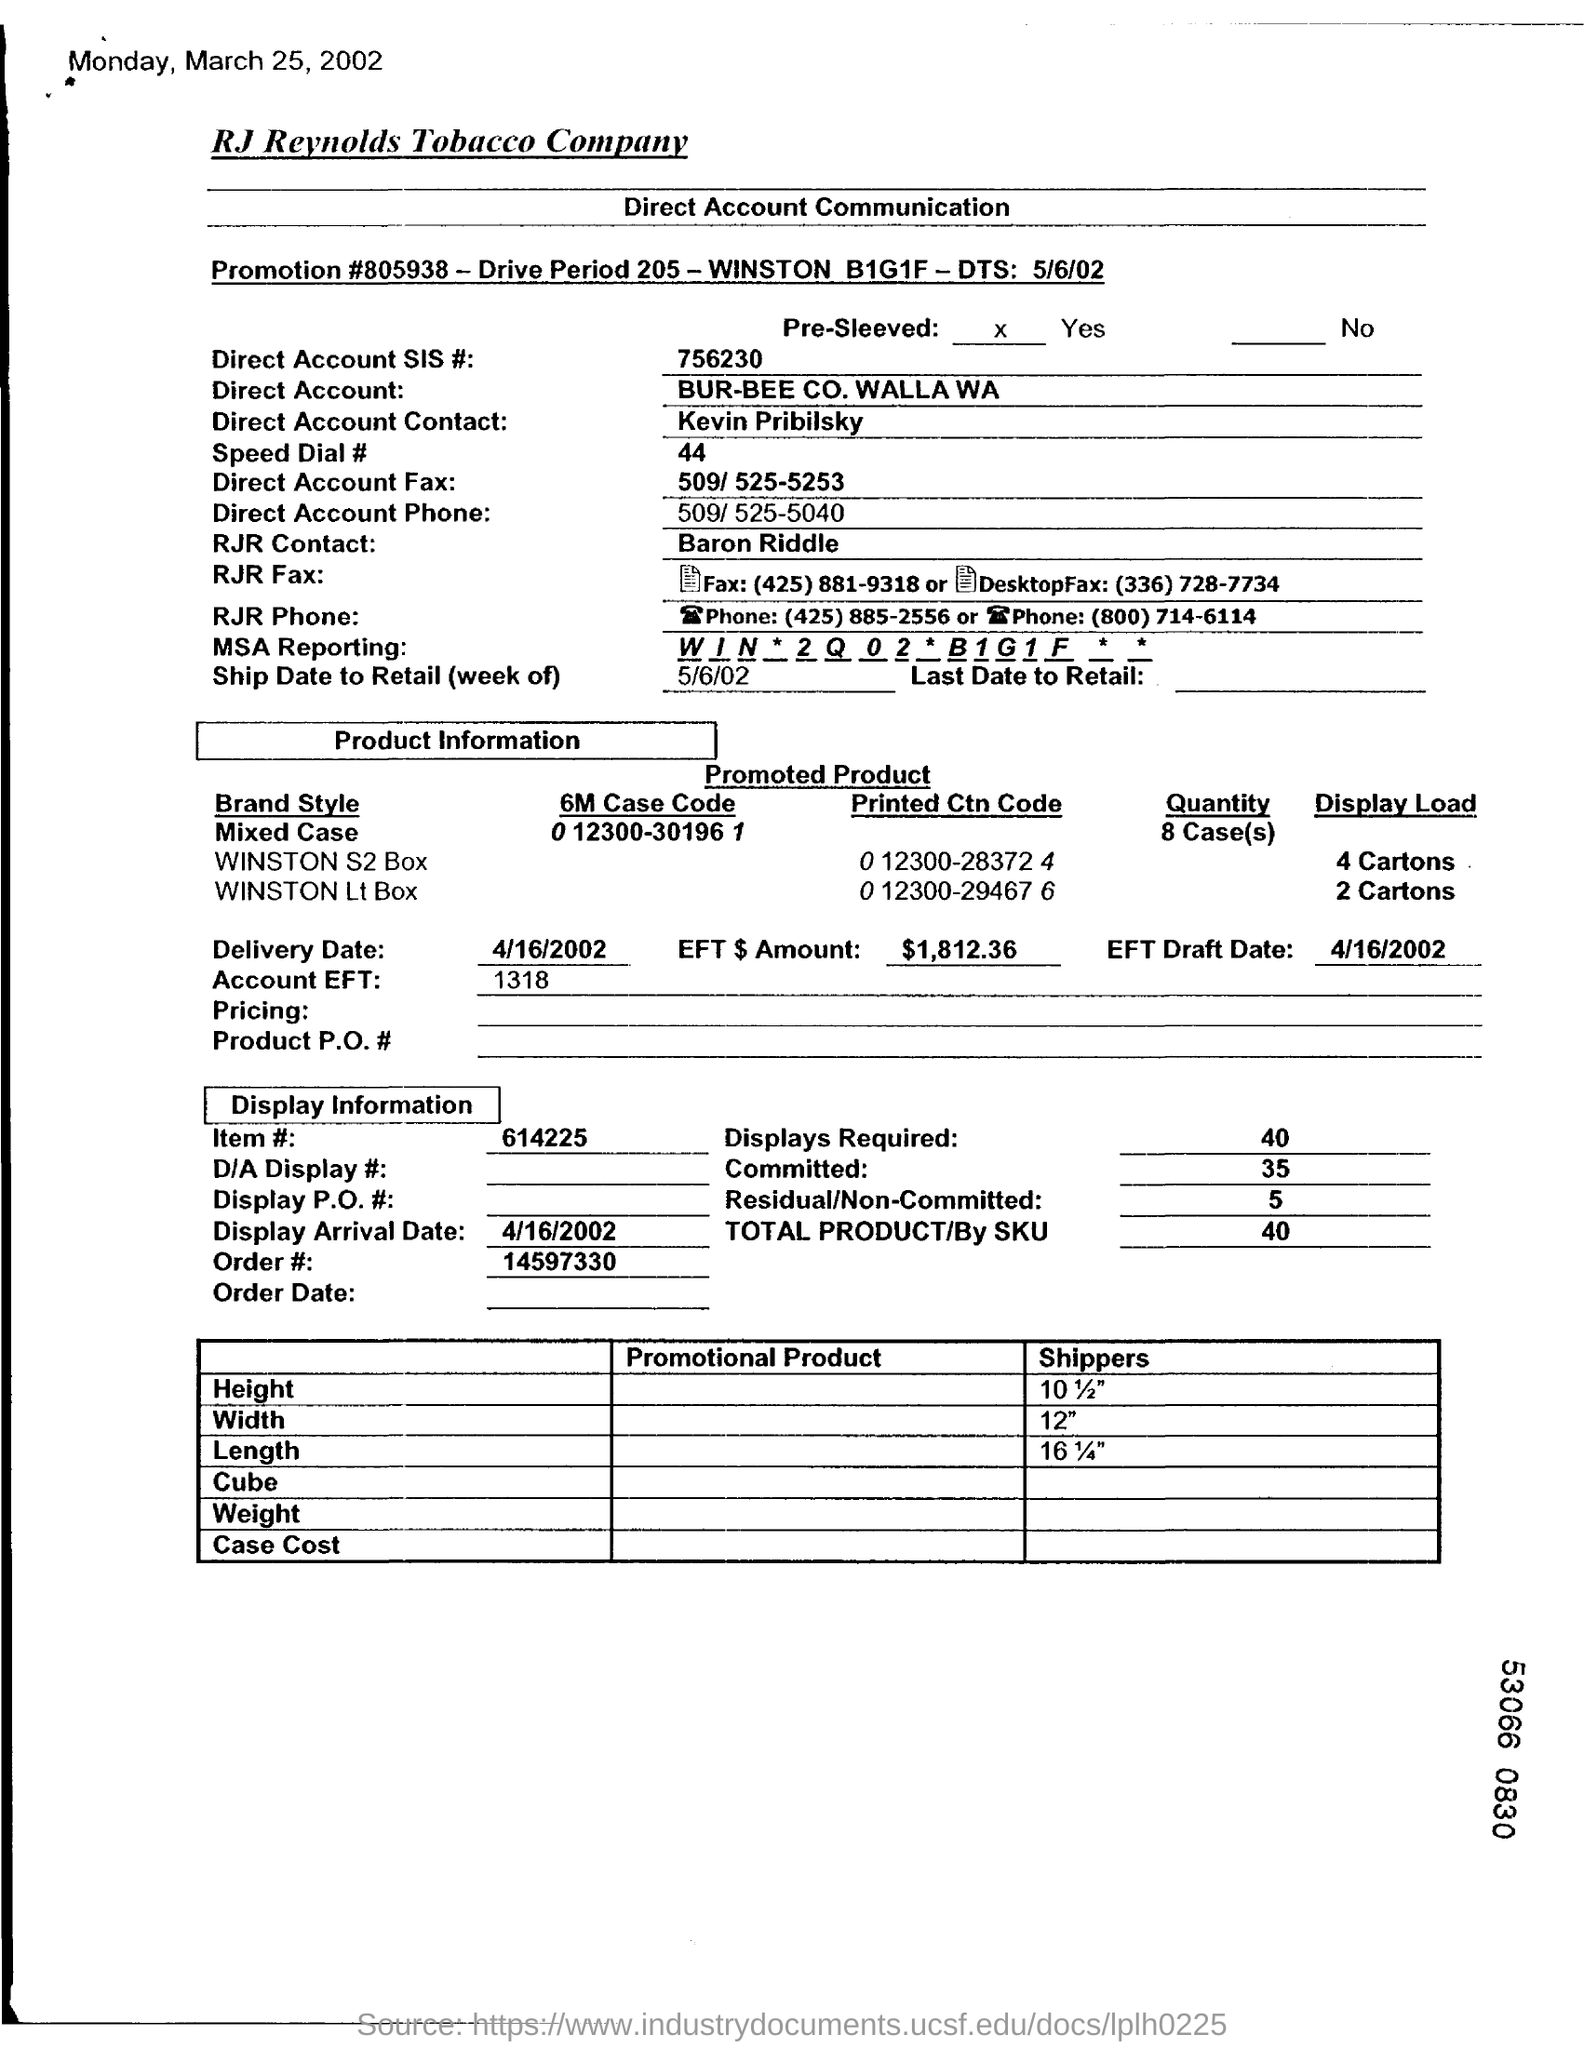Mention a couple of crucial points in this snapshot. Baron Riddle is the RJR contact. The arrival date of the display will be on April 16, 2002. 